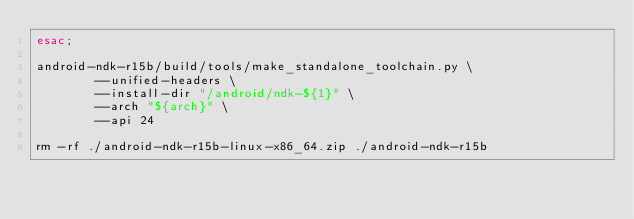<code> <loc_0><loc_0><loc_500><loc_500><_Bash_>esac;

android-ndk-r15b/build/tools/make_standalone_toolchain.py \
        --unified-headers \
        --install-dir "/android/ndk-${1}" \
        --arch "${arch}" \
        --api 24

rm -rf ./android-ndk-r15b-linux-x86_64.zip ./android-ndk-r15b
</code> 